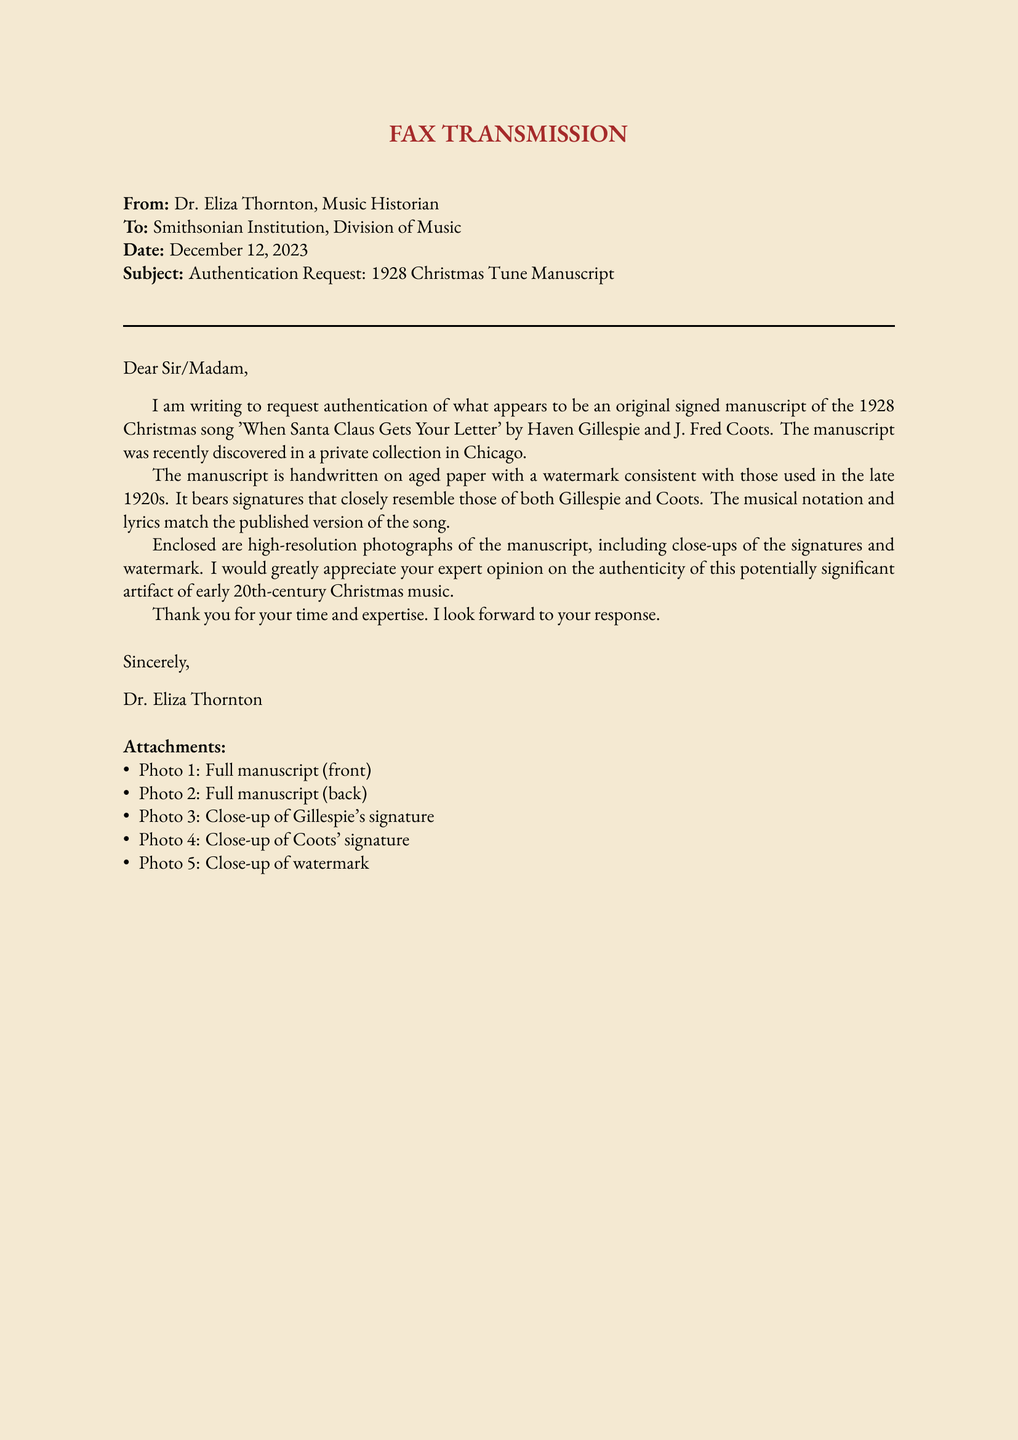What is the subject of the fax? The subject of the fax is explicitly stated in the document as "Authentication Request: 1928 Christmas Tune Manuscript."
Answer: Authentication Request: 1928 Christmas Tune Manuscript Who is the sender of the fax? The sender is identified at the beginning of the document as Dr. Eliza Thornton, Music Historian.
Answer: Dr. Eliza Thornton What song is mentioned in the document? The song referenced in the fax is 'When Santa Claus Gets Your Letter'.
Answer: When Santa Claus Gets Your Letter What year was the song composed? The year the song was composed is clearly mentioned in the document as 1928.
Answer: 1928 Where was the manuscript discovered? The document specifies that the manuscript was discovered in a private collection in Chicago.
Answer: Chicago How many photographs are attached to the fax? The number of photographs listed in the attachments section of the fax is five.
Answer: five What do the photographs include? The described content of the photographs includes the full manuscript, close-ups of signatures, and a watermark.
Answer: Full manuscript, signatures, watermark What is the purpose of the request in the fax? The purpose of the request in the fax is to seek authentication of the original signed manuscript.
Answer: Authentication of the original signed manuscript To whom is the fax addressed? The fax is addressed to the Smithsonian Institution, Division of Music.
Answer: Smithsonian Institution, Division of Music 